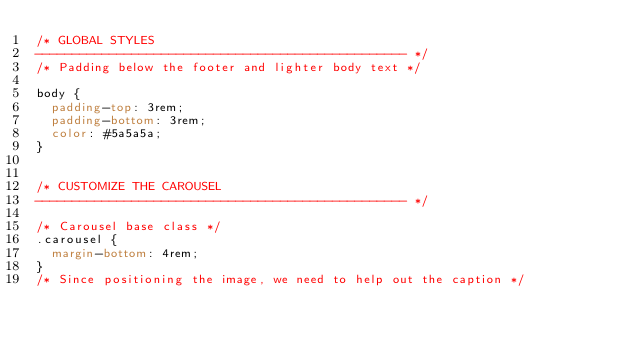<code> <loc_0><loc_0><loc_500><loc_500><_CSS_>/* GLOBAL STYLES
-------------------------------------------------- */
/* Padding below the footer and lighter body text */

body {
  padding-top: 3rem;
  padding-bottom: 3rem;
  color: #5a5a5a;
}


/* CUSTOMIZE THE CAROUSEL
-------------------------------------------------- */

/* Carousel base class */
.carousel {
  margin-bottom: 4rem;
}
/* Since positioning the image, we need to help out the caption */</code> 